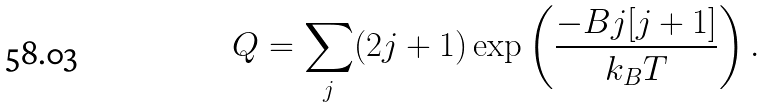<formula> <loc_0><loc_0><loc_500><loc_500>Q = \sum _ { j } ( 2 j + 1 ) \exp \left ( \frac { - B j [ j + 1 ] } { k _ { B } T } \right ) .</formula> 